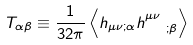<formula> <loc_0><loc_0><loc_500><loc_500>T _ { \alpha \beta } \equiv \frac { 1 } { 3 2 \pi } \left \langle h _ { \mu \nu ; \alpha } h ^ { \mu \nu } _ { \ \ ; \beta } \right \rangle</formula> 